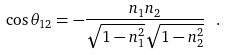<formula> <loc_0><loc_0><loc_500><loc_500>\cos { { \theta } _ { 1 2 } } = - \frac { n _ { 1 } n _ { 2 } } { \sqrt { 1 - n _ { 1 } ^ { 2 } } \sqrt { 1 - n _ { 2 } ^ { 2 } } } \ .</formula> 